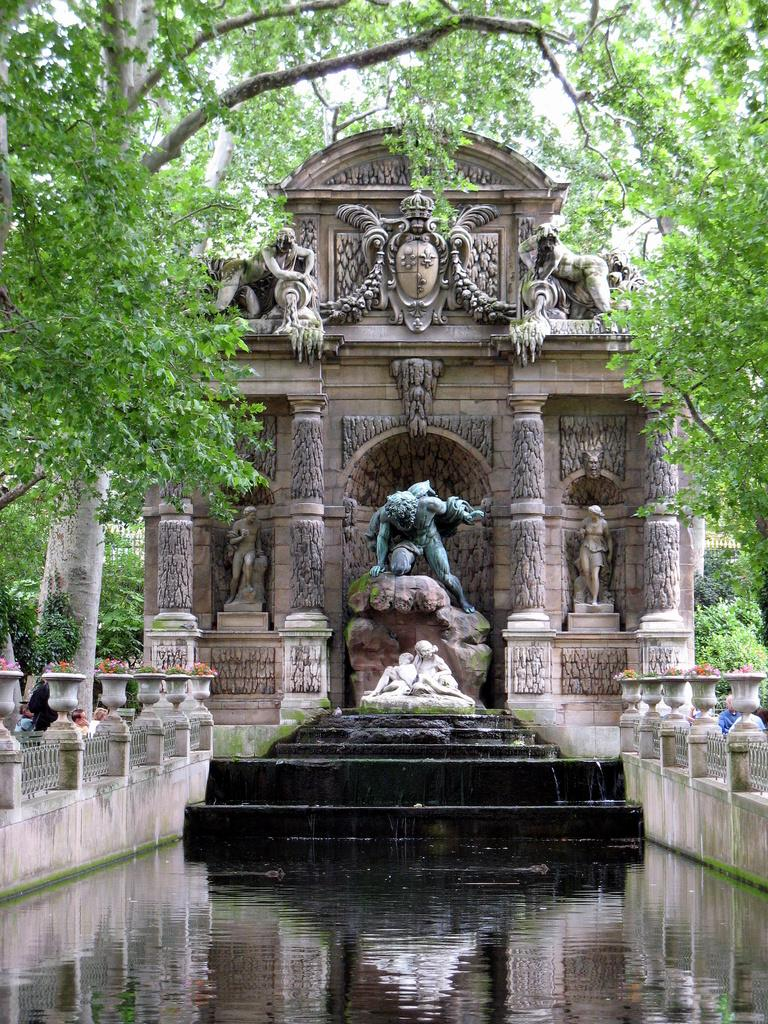What is the main subject in the center of the image? There is a statue and a water fountain in the center of the image. What can be found on the wall in the image? There are sculptures on the wall. What type of vegetation is visible in the image? There are trees visible in the image. Can you describe the people in the image? There are people in the image. What type of decorative items can be seen in the image? There are flower pots in the image. What type of shoes are the statues wearing in the image? The statues in the image are not wearing shoes, as they are not human figures. 